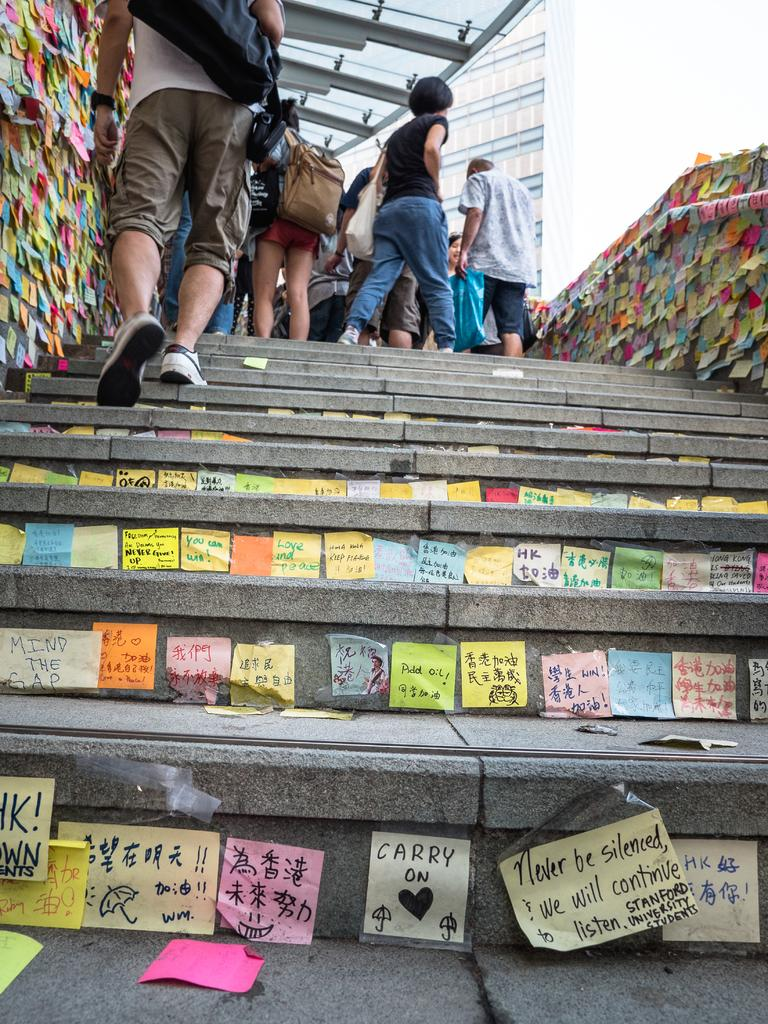<image>
Render a clear and concise summary of the photo. a sign with many others that says carry on on it 